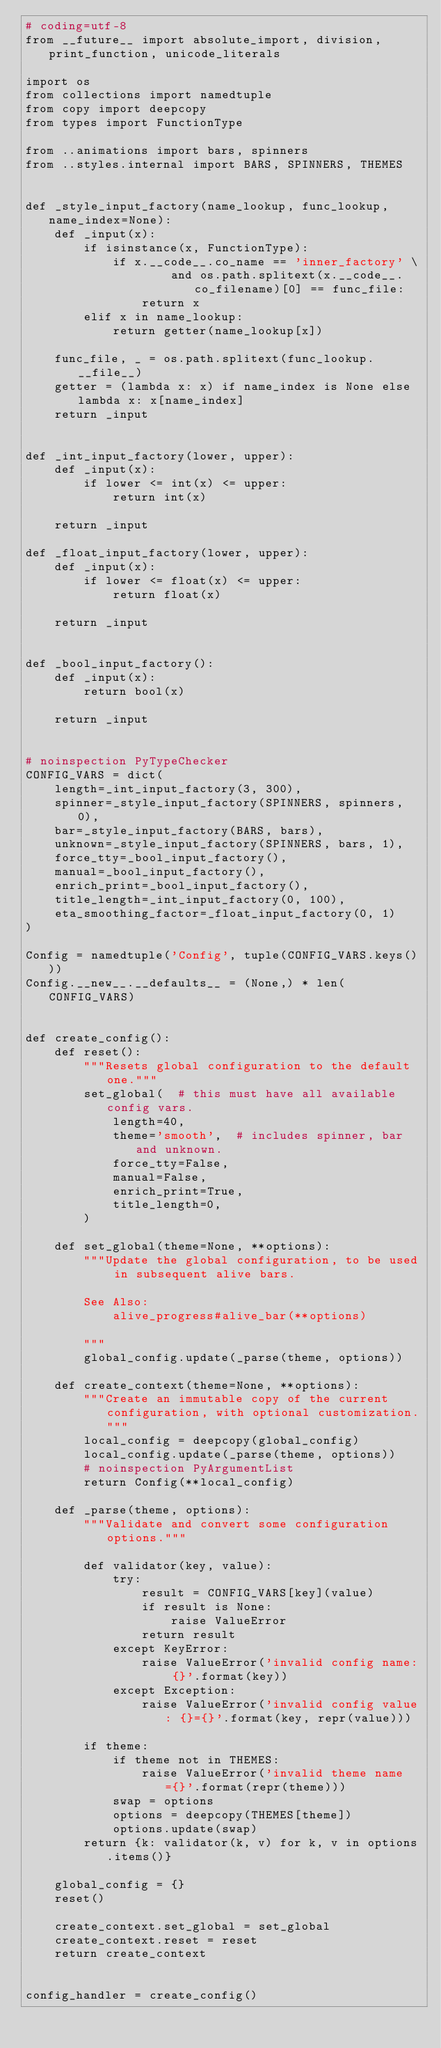<code> <loc_0><loc_0><loc_500><loc_500><_Python_># coding=utf-8
from __future__ import absolute_import, division, print_function, unicode_literals

import os
from collections import namedtuple
from copy import deepcopy
from types import FunctionType

from ..animations import bars, spinners
from ..styles.internal import BARS, SPINNERS, THEMES


def _style_input_factory(name_lookup, func_lookup, name_index=None):
    def _input(x):
        if isinstance(x, FunctionType):
            if x.__code__.co_name == 'inner_factory' \
                    and os.path.splitext(x.__code__.co_filename)[0] == func_file:
                return x
        elif x in name_lookup:
            return getter(name_lookup[x])

    func_file, _ = os.path.splitext(func_lookup.__file__)
    getter = (lambda x: x) if name_index is None else lambda x: x[name_index]
    return _input


def _int_input_factory(lower, upper):
    def _input(x):
        if lower <= int(x) <= upper:
            return int(x)

    return _input

def _float_input_factory(lower, upper):
    def _input(x):
        if lower <= float(x) <= upper:
            return float(x)
    
    return _input


def _bool_input_factory():
    def _input(x):
        return bool(x)

    return _input


# noinspection PyTypeChecker
CONFIG_VARS = dict(
    length=_int_input_factory(3, 300),
    spinner=_style_input_factory(SPINNERS, spinners, 0),
    bar=_style_input_factory(BARS, bars),
    unknown=_style_input_factory(SPINNERS, bars, 1),
    force_tty=_bool_input_factory(),
    manual=_bool_input_factory(),
    enrich_print=_bool_input_factory(),
    title_length=_int_input_factory(0, 100),
    eta_smoothing_factor=_float_input_factory(0, 1)
)

Config = namedtuple('Config', tuple(CONFIG_VARS.keys()))
Config.__new__.__defaults__ = (None,) * len(CONFIG_VARS)


def create_config():
    def reset():
        """Resets global configuration to the default one."""
        set_global(  # this must have all available config vars.
            length=40,
            theme='smooth',  # includes spinner, bar and unknown.
            force_tty=False,
            manual=False,
            enrich_print=True,
            title_length=0,
        )

    def set_global(theme=None, **options):
        """Update the global configuration, to be used in subsequent alive bars.

        See Also:
            alive_progress#alive_bar(**options)

        """
        global_config.update(_parse(theme, options))

    def create_context(theme=None, **options):
        """Create an immutable copy of the current configuration, with optional customization."""
        local_config = deepcopy(global_config)
        local_config.update(_parse(theme, options))
        # noinspection PyArgumentList
        return Config(**local_config)

    def _parse(theme, options):
        """Validate and convert some configuration options."""

        def validator(key, value):
            try:
                result = CONFIG_VARS[key](value)
                if result is None:
                    raise ValueError
                return result
            except KeyError:
                raise ValueError('invalid config name: {}'.format(key))
            except Exception:
                raise ValueError('invalid config value: {}={}'.format(key, repr(value)))

        if theme:
            if theme not in THEMES:
                raise ValueError('invalid theme name={}'.format(repr(theme)))
            swap = options
            options = deepcopy(THEMES[theme])
            options.update(swap)
        return {k: validator(k, v) for k, v in options.items()}

    global_config = {}
    reset()

    create_context.set_global = set_global
    create_context.reset = reset
    return create_context


config_handler = create_config()
</code> 